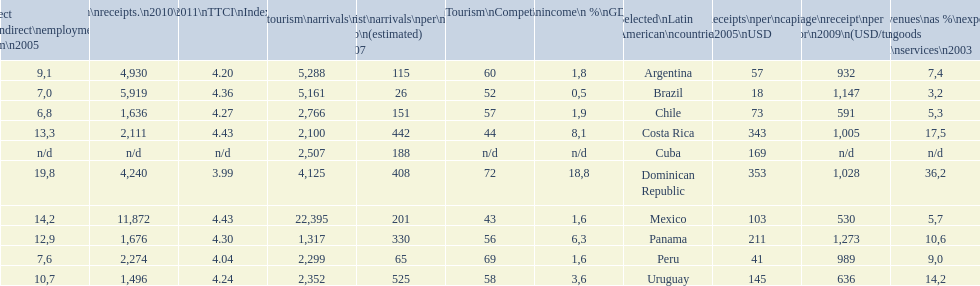What country ranks the best in most categories? Dominican Republic. 